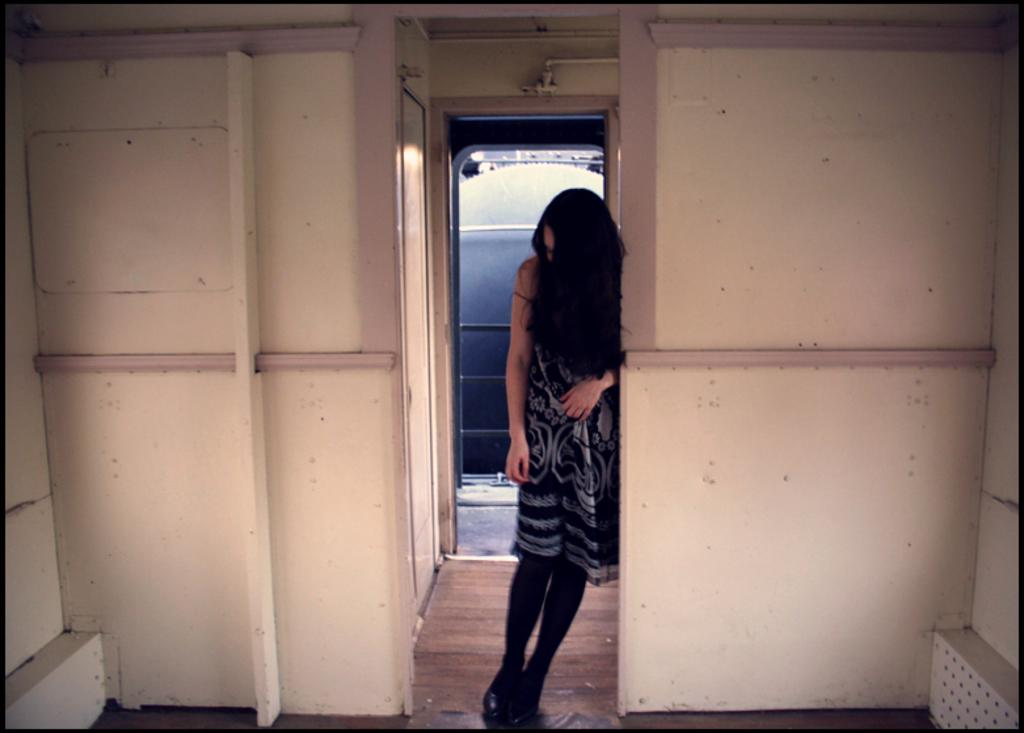Who is the main subject in the image? There is a lady standing in the center of the image. What can be seen behind the lady? There is a wall in the background of the image. What is the lady standing on? There is a floor at the bottom of the image. What is visible at the top of the image? There are pipes visible at the top of the image. What is the name of the lady in the image? The provided facts do not mention the name of the lady, so we cannot determine her name from the image. 